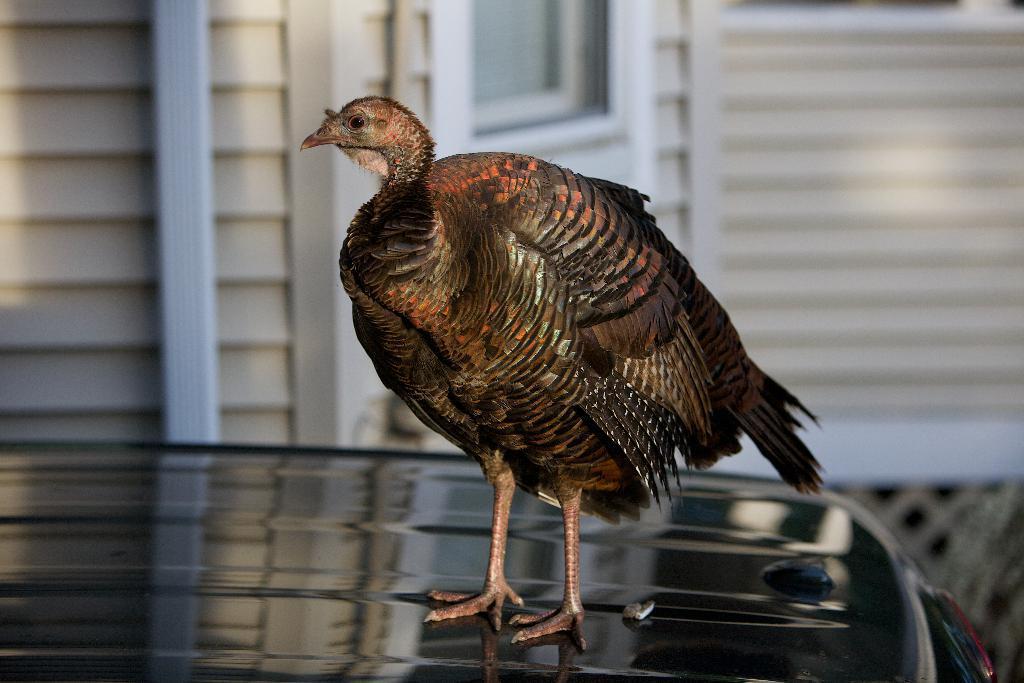Please provide a concise description of this image. In the center of the image a baby ostrich is present on the car. In the background of the image we can see a window, wall are present. 